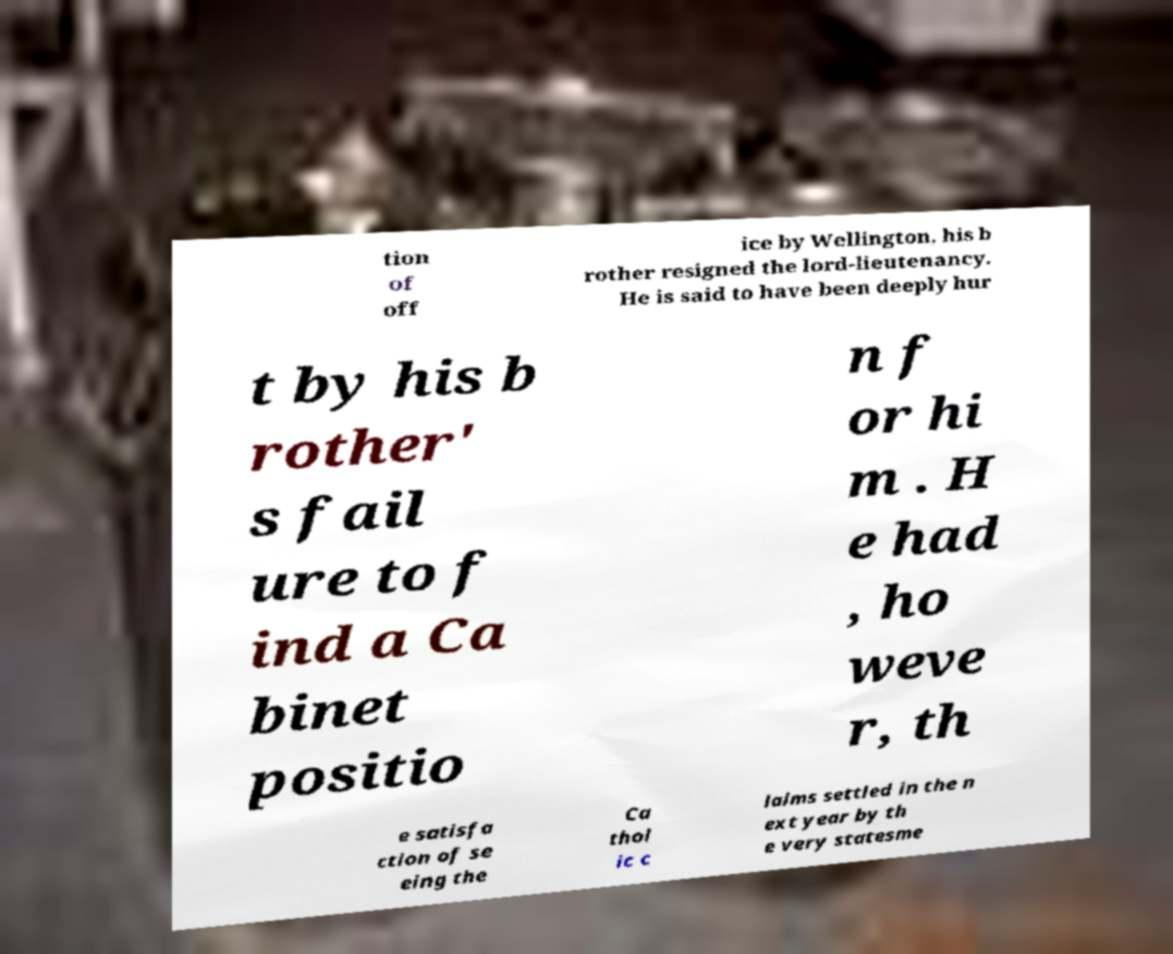Please identify and transcribe the text found in this image. tion of off ice by Wellington, his b rother resigned the lord-lieutenancy. He is said to have been deeply hur t by his b rother' s fail ure to f ind a Ca binet positio n f or hi m . H e had , ho weve r, th e satisfa ction of se eing the Ca thol ic c laims settled in the n ext year by th e very statesme 